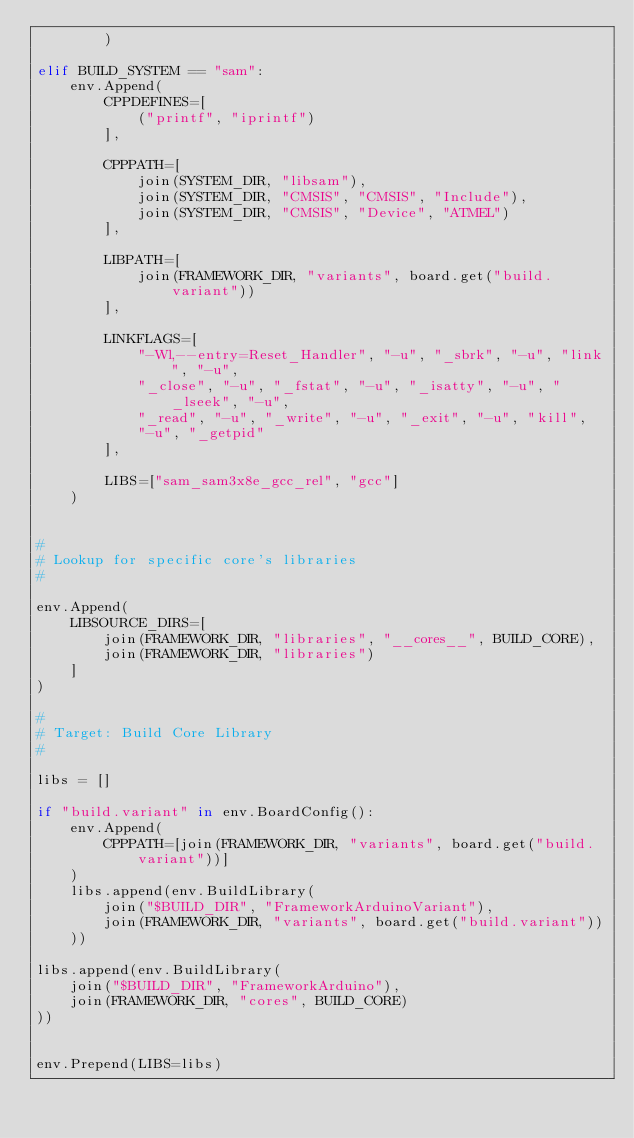<code> <loc_0><loc_0><loc_500><loc_500><_Python_>        )

elif BUILD_SYSTEM == "sam":
    env.Append(
        CPPDEFINES=[
            ("printf", "iprintf")
        ],

        CPPPATH=[
            join(SYSTEM_DIR, "libsam"),
            join(SYSTEM_DIR, "CMSIS", "CMSIS", "Include"),
            join(SYSTEM_DIR, "CMSIS", "Device", "ATMEL")
        ],

        LIBPATH=[
            join(FRAMEWORK_DIR, "variants", board.get("build.variant"))
        ],

        LINKFLAGS=[
            "-Wl,--entry=Reset_Handler", "-u", "_sbrk", "-u", "link", "-u",
            "_close", "-u", "_fstat", "-u", "_isatty", "-u", "_lseek", "-u",
            "_read", "-u", "_write", "-u", "_exit", "-u", "kill",
            "-u", "_getpid"
        ],

        LIBS=["sam_sam3x8e_gcc_rel", "gcc"]
    )


#
# Lookup for specific core's libraries
#

env.Append(
    LIBSOURCE_DIRS=[
        join(FRAMEWORK_DIR, "libraries", "__cores__", BUILD_CORE),
        join(FRAMEWORK_DIR, "libraries")
    ]
)

#
# Target: Build Core Library
#

libs = []

if "build.variant" in env.BoardConfig():
    env.Append(
        CPPPATH=[join(FRAMEWORK_DIR, "variants", board.get("build.variant"))]
    )
    libs.append(env.BuildLibrary(
        join("$BUILD_DIR", "FrameworkArduinoVariant"),
        join(FRAMEWORK_DIR, "variants", board.get("build.variant"))
    ))

libs.append(env.BuildLibrary(
    join("$BUILD_DIR", "FrameworkArduino"),
    join(FRAMEWORK_DIR, "cores", BUILD_CORE)
))


env.Prepend(LIBS=libs)
</code> 